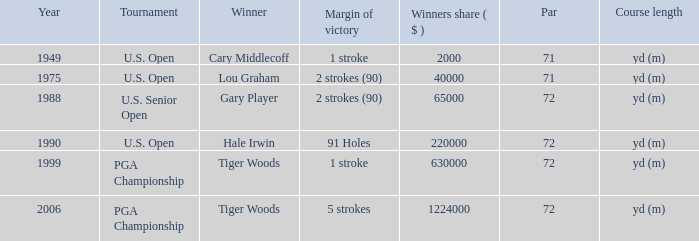When cary middlecoff is the winner how many pars are there? 1.0. 